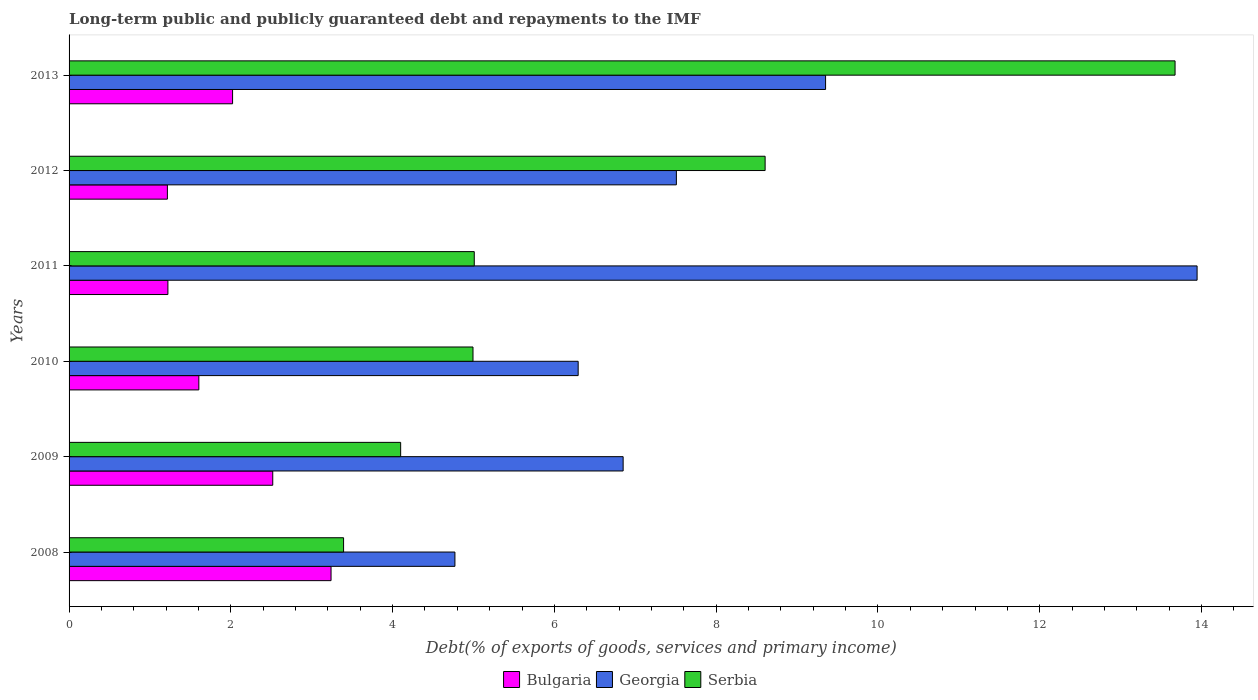How many different coloured bars are there?
Offer a terse response. 3. How many groups of bars are there?
Ensure brevity in your answer.  6. Are the number of bars per tick equal to the number of legend labels?
Make the answer very short. Yes. How many bars are there on the 3rd tick from the top?
Offer a very short reply. 3. What is the debt and repayments in Bulgaria in 2009?
Offer a terse response. 2.52. Across all years, what is the maximum debt and repayments in Bulgaria?
Ensure brevity in your answer.  3.24. Across all years, what is the minimum debt and repayments in Serbia?
Your answer should be very brief. 3.39. In which year was the debt and repayments in Serbia maximum?
Offer a very short reply. 2013. What is the total debt and repayments in Georgia in the graph?
Give a very brief answer. 48.72. What is the difference between the debt and repayments in Serbia in 2012 and that in 2013?
Give a very brief answer. -5.07. What is the difference between the debt and repayments in Georgia in 2011 and the debt and repayments in Serbia in 2008?
Your answer should be compact. 10.55. What is the average debt and repayments in Bulgaria per year?
Give a very brief answer. 1.97. In the year 2011, what is the difference between the debt and repayments in Serbia and debt and repayments in Bulgaria?
Provide a short and direct response. 3.79. What is the ratio of the debt and repayments in Georgia in 2009 to that in 2010?
Keep it short and to the point. 1.09. Is the debt and repayments in Bulgaria in 2008 less than that in 2012?
Your answer should be very brief. No. Is the difference between the debt and repayments in Serbia in 2010 and 2012 greater than the difference between the debt and repayments in Bulgaria in 2010 and 2012?
Your answer should be very brief. No. What is the difference between the highest and the second highest debt and repayments in Serbia?
Keep it short and to the point. 5.07. What is the difference between the highest and the lowest debt and repayments in Georgia?
Offer a terse response. 9.18. In how many years, is the debt and repayments in Georgia greater than the average debt and repayments in Georgia taken over all years?
Give a very brief answer. 2. Is the sum of the debt and repayments in Georgia in 2008 and 2012 greater than the maximum debt and repayments in Serbia across all years?
Provide a short and direct response. No. What does the 2nd bar from the top in 2012 represents?
Your response must be concise. Georgia. What does the 1st bar from the bottom in 2009 represents?
Offer a terse response. Bulgaria. Is it the case that in every year, the sum of the debt and repayments in Serbia and debt and repayments in Bulgaria is greater than the debt and repayments in Georgia?
Offer a very short reply. No. What is the difference between two consecutive major ticks on the X-axis?
Provide a succinct answer. 2. Does the graph contain grids?
Provide a short and direct response. No. Where does the legend appear in the graph?
Your response must be concise. Bottom center. How many legend labels are there?
Provide a succinct answer. 3. How are the legend labels stacked?
Offer a terse response. Horizontal. What is the title of the graph?
Keep it short and to the point. Long-term public and publicly guaranteed debt and repayments to the IMF. Does "Tonga" appear as one of the legend labels in the graph?
Ensure brevity in your answer.  No. What is the label or title of the X-axis?
Give a very brief answer. Debt(% of exports of goods, services and primary income). What is the Debt(% of exports of goods, services and primary income) in Bulgaria in 2008?
Your response must be concise. 3.24. What is the Debt(% of exports of goods, services and primary income) of Georgia in 2008?
Make the answer very short. 4.77. What is the Debt(% of exports of goods, services and primary income) in Serbia in 2008?
Your answer should be compact. 3.39. What is the Debt(% of exports of goods, services and primary income) of Bulgaria in 2009?
Offer a terse response. 2.52. What is the Debt(% of exports of goods, services and primary income) of Georgia in 2009?
Make the answer very short. 6.85. What is the Debt(% of exports of goods, services and primary income) of Serbia in 2009?
Provide a succinct answer. 4.1. What is the Debt(% of exports of goods, services and primary income) in Bulgaria in 2010?
Provide a succinct answer. 1.6. What is the Debt(% of exports of goods, services and primary income) in Georgia in 2010?
Offer a terse response. 6.29. What is the Debt(% of exports of goods, services and primary income) in Serbia in 2010?
Your answer should be compact. 4.99. What is the Debt(% of exports of goods, services and primary income) in Bulgaria in 2011?
Offer a terse response. 1.22. What is the Debt(% of exports of goods, services and primary income) in Georgia in 2011?
Your answer should be very brief. 13.95. What is the Debt(% of exports of goods, services and primary income) in Serbia in 2011?
Offer a terse response. 5.01. What is the Debt(% of exports of goods, services and primary income) of Bulgaria in 2012?
Your answer should be compact. 1.22. What is the Debt(% of exports of goods, services and primary income) of Georgia in 2012?
Your answer should be compact. 7.51. What is the Debt(% of exports of goods, services and primary income) of Serbia in 2012?
Your answer should be compact. 8.6. What is the Debt(% of exports of goods, services and primary income) of Bulgaria in 2013?
Provide a succinct answer. 2.02. What is the Debt(% of exports of goods, services and primary income) in Georgia in 2013?
Offer a terse response. 9.35. What is the Debt(% of exports of goods, services and primary income) of Serbia in 2013?
Your answer should be very brief. 13.67. Across all years, what is the maximum Debt(% of exports of goods, services and primary income) in Bulgaria?
Your answer should be compact. 3.24. Across all years, what is the maximum Debt(% of exports of goods, services and primary income) in Georgia?
Make the answer very short. 13.95. Across all years, what is the maximum Debt(% of exports of goods, services and primary income) in Serbia?
Provide a succinct answer. 13.67. Across all years, what is the minimum Debt(% of exports of goods, services and primary income) of Bulgaria?
Give a very brief answer. 1.22. Across all years, what is the minimum Debt(% of exports of goods, services and primary income) of Georgia?
Offer a very short reply. 4.77. Across all years, what is the minimum Debt(% of exports of goods, services and primary income) of Serbia?
Provide a short and direct response. 3.39. What is the total Debt(% of exports of goods, services and primary income) of Bulgaria in the graph?
Provide a succinct answer. 11.82. What is the total Debt(% of exports of goods, services and primary income) in Georgia in the graph?
Keep it short and to the point. 48.72. What is the total Debt(% of exports of goods, services and primary income) in Serbia in the graph?
Keep it short and to the point. 39.77. What is the difference between the Debt(% of exports of goods, services and primary income) of Bulgaria in 2008 and that in 2009?
Your response must be concise. 0.72. What is the difference between the Debt(% of exports of goods, services and primary income) of Georgia in 2008 and that in 2009?
Give a very brief answer. -2.08. What is the difference between the Debt(% of exports of goods, services and primary income) of Serbia in 2008 and that in 2009?
Offer a terse response. -0.71. What is the difference between the Debt(% of exports of goods, services and primary income) of Bulgaria in 2008 and that in 2010?
Your response must be concise. 1.63. What is the difference between the Debt(% of exports of goods, services and primary income) in Georgia in 2008 and that in 2010?
Keep it short and to the point. -1.52. What is the difference between the Debt(% of exports of goods, services and primary income) of Bulgaria in 2008 and that in 2011?
Offer a terse response. 2.02. What is the difference between the Debt(% of exports of goods, services and primary income) of Georgia in 2008 and that in 2011?
Keep it short and to the point. -9.18. What is the difference between the Debt(% of exports of goods, services and primary income) in Serbia in 2008 and that in 2011?
Make the answer very short. -1.62. What is the difference between the Debt(% of exports of goods, services and primary income) of Bulgaria in 2008 and that in 2012?
Keep it short and to the point. 2.02. What is the difference between the Debt(% of exports of goods, services and primary income) of Georgia in 2008 and that in 2012?
Provide a succinct answer. -2.74. What is the difference between the Debt(% of exports of goods, services and primary income) in Serbia in 2008 and that in 2012?
Ensure brevity in your answer.  -5.21. What is the difference between the Debt(% of exports of goods, services and primary income) in Bulgaria in 2008 and that in 2013?
Your answer should be compact. 1.22. What is the difference between the Debt(% of exports of goods, services and primary income) of Georgia in 2008 and that in 2013?
Provide a succinct answer. -4.58. What is the difference between the Debt(% of exports of goods, services and primary income) of Serbia in 2008 and that in 2013?
Keep it short and to the point. -10.28. What is the difference between the Debt(% of exports of goods, services and primary income) in Bulgaria in 2009 and that in 2010?
Your response must be concise. 0.91. What is the difference between the Debt(% of exports of goods, services and primary income) in Georgia in 2009 and that in 2010?
Keep it short and to the point. 0.56. What is the difference between the Debt(% of exports of goods, services and primary income) of Serbia in 2009 and that in 2010?
Give a very brief answer. -0.89. What is the difference between the Debt(% of exports of goods, services and primary income) in Bulgaria in 2009 and that in 2011?
Provide a succinct answer. 1.3. What is the difference between the Debt(% of exports of goods, services and primary income) of Georgia in 2009 and that in 2011?
Your answer should be very brief. -7.1. What is the difference between the Debt(% of exports of goods, services and primary income) of Serbia in 2009 and that in 2011?
Offer a terse response. -0.91. What is the difference between the Debt(% of exports of goods, services and primary income) in Bulgaria in 2009 and that in 2012?
Your response must be concise. 1.3. What is the difference between the Debt(% of exports of goods, services and primary income) of Georgia in 2009 and that in 2012?
Provide a succinct answer. -0.66. What is the difference between the Debt(% of exports of goods, services and primary income) in Serbia in 2009 and that in 2012?
Keep it short and to the point. -4.51. What is the difference between the Debt(% of exports of goods, services and primary income) in Bulgaria in 2009 and that in 2013?
Your answer should be very brief. 0.5. What is the difference between the Debt(% of exports of goods, services and primary income) in Georgia in 2009 and that in 2013?
Make the answer very short. -2.5. What is the difference between the Debt(% of exports of goods, services and primary income) of Serbia in 2009 and that in 2013?
Give a very brief answer. -9.57. What is the difference between the Debt(% of exports of goods, services and primary income) of Bulgaria in 2010 and that in 2011?
Provide a short and direct response. 0.38. What is the difference between the Debt(% of exports of goods, services and primary income) of Georgia in 2010 and that in 2011?
Your answer should be very brief. -7.65. What is the difference between the Debt(% of exports of goods, services and primary income) of Serbia in 2010 and that in 2011?
Your answer should be very brief. -0.02. What is the difference between the Debt(% of exports of goods, services and primary income) in Bulgaria in 2010 and that in 2012?
Offer a terse response. 0.39. What is the difference between the Debt(% of exports of goods, services and primary income) in Georgia in 2010 and that in 2012?
Your answer should be compact. -1.21. What is the difference between the Debt(% of exports of goods, services and primary income) in Serbia in 2010 and that in 2012?
Your answer should be compact. -3.61. What is the difference between the Debt(% of exports of goods, services and primary income) in Bulgaria in 2010 and that in 2013?
Your answer should be compact. -0.42. What is the difference between the Debt(% of exports of goods, services and primary income) of Georgia in 2010 and that in 2013?
Offer a terse response. -3.06. What is the difference between the Debt(% of exports of goods, services and primary income) in Serbia in 2010 and that in 2013?
Provide a short and direct response. -8.68. What is the difference between the Debt(% of exports of goods, services and primary income) of Bulgaria in 2011 and that in 2012?
Provide a succinct answer. 0.01. What is the difference between the Debt(% of exports of goods, services and primary income) in Georgia in 2011 and that in 2012?
Provide a succinct answer. 6.44. What is the difference between the Debt(% of exports of goods, services and primary income) in Serbia in 2011 and that in 2012?
Keep it short and to the point. -3.6. What is the difference between the Debt(% of exports of goods, services and primary income) in Bulgaria in 2011 and that in 2013?
Offer a very short reply. -0.8. What is the difference between the Debt(% of exports of goods, services and primary income) of Georgia in 2011 and that in 2013?
Keep it short and to the point. 4.59. What is the difference between the Debt(% of exports of goods, services and primary income) in Serbia in 2011 and that in 2013?
Provide a succinct answer. -8.66. What is the difference between the Debt(% of exports of goods, services and primary income) in Bulgaria in 2012 and that in 2013?
Your answer should be very brief. -0.81. What is the difference between the Debt(% of exports of goods, services and primary income) of Georgia in 2012 and that in 2013?
Your answer should be compact. -1.84. What is the difference between the Debt(% of exports of goods, services and primary income) of Serbia in 2012 and that in 2013?
Your answer should be compact. -5.07. What is the difference between the Debt(% of exports of goods, services and primary income) of Bulgaria in 2008 and the Debt(% of exports of goods, services and primary income) of Georgia in 2009?
Provide a short and direct response. -3.61. What is the difference between the Debt(% of exports of goods, services and primary income) in Bulgaria in 2008 and the Debt(% of exports of goods, services and primary income) in Serbia in 2009?
Your answer should be very brief. -0.86. What is the difference between the Debt(% of exports of goods, services and primary income) in Georgia in 2008 and the Debt(% of exports of goods, services and primary income) in Serbia in 2009?
Your answer should be very brief. 0.67. What is the difference between the Debt(% of exports of goods, services and primary income) of Bulgaria in 2008 and the Debt(% of exports of goods, services and primary income) of Georgia in 2010?
Offer a very short reply. -3.06. What is the difference between the Debt(% of exports of goods, services and primary income) of Bulgaria in 2008 and the Debt(% of exports of goods, services and primary income) of Serbia in 2010?
Offer a very short reply. -1.75. What is the difference between the Debt(% of exports of goods, services and primary income) in Georgia in 2008 and the Debt(% of exports of goods, services and primary income) in Serbia in 2010?
Offer a terse response. -0.22. What is the difference between the Debt(% of exports of goods, services and primary income) of Bulgaria in 2008 and the Debt(% of exports of goods, services and primary income) of Georgia in 2011?
Keep it short and to the point. -10.71. What is the difference between the Debt(% of exports of goods, services and primary income) of Bulgaria in 2008 and the Debt(% of exports of goods, services and primary income) of Serbia in 2011?
Your answer should be very brief. -1.77. What is the difference between the Debt(% of exports of goods, services and primary income) in Georgia in 2008 and the Debt(% of exports of goods, services and primary income) in Serbia in 2011?
Provide a succinct answer. -0.24. What is the difference between the Debt(% of exports of goods, services and primary income) of Bulgaria in 2008 and the Debt(% of exports of goods, services and primary income) of Georgia in 2012?
Provide a succinct answer. -4.27. What is the difference between the Debt(% of exports of goods, services and primary income) in Bulgaria in 2008 and the Debt(% of exports of goods, services and primary income) in Serbia in 2012?
Make the answer very short. -5.37. What is the difference between the Debt(% of exports of goods, services and primary income) in Georgia in 2008 and the Debt(% of exports of goods, services and primary income) in Serbia in 2012?
Make the answer very short. -3.83. What is the difference between the Debt(% of exports of goods, services and primary income) of Bulgaria in 2008 and the Debt(% of exports of goods, services and primary income) of Georgia in 2013?
Your answer should be very brief. -6.11. What is the difference between the Debt(% of exports of goods, services and primary income) in Bulgaria in 2008 and the Debt(% of exports of goods, services and primary income) in Serbia in 2013?
Your answer should be very brief. -10.43. What is the difference between the Debt(% of exports of goods, services and primary income) in Georgia in 2008 and the Debt(% of exports of goods, services and primary income) in Serbia in 2013?
Give a very brief answer. -8.9. What is the difference between the Debt(% of exports of goods, services and primary income) in Bulgaria in 2009 and the Debt(% of exports of goods, services and primary income) in Georgia in 2010?
Provide a short and direct response. -3.78. What is the difference between the Debt(% of exports of goods, services and primary income) of Bulgaria in 2009 and the Debt(% of exports of goods, services and primary income) of Serbia in 2010?
Offer a very short reply. -2.48. What is the difference between the Debt(% of exports of goods, services and primary income) of Georgia in 2009 and the Debt(% of exports of goods, services and primary income) of Serbia in 2010?
Your answer should be compact. 1.86. What is the difference between the Debt(% of exports of goods, services and primary income) of Bulgaria in 2009 and the Debt(% of exports of goods, services and primary income) of Georgia in 2011?
Offer a very short reply. -11.43. What is the difference between the Debt(% of exports of goods, services and primary income) of Bulgaria in 2009 and the Debt(% of exports of goods, services and primary income) of Serbia in 2011?
Ensure brevity in your answer.  -2.49. What is the difference between the Debt(% of exports of goods, services and primary income) in Georgia in 2009 and the Debt(% of exports of goods, services and primary income) in Serbia in 2011?
Keep it short and to the point. 1.84. What is the difference between the Debt(% of exports of goods, services and primary income) in Bulgaria in 2009 and the Debt(% of exports of goods, services and primary income) in Georgia in 2012?
Provide a succinct answer. -4.99. What is the difference between the Debt(% of exports of goods, services and primary income) of Bulgaria in 2009 and the Debt(% of exports of goods, services and primary income) of Serbia in 2012?
Your answer should be very brief. -6.09. What is the difference between the Debt(% of exports of goods, services and primary income) of Georgia in 2009 and the Debt(% of exports of goods, services and primary income) of Serbia in 2012?
Ensure brevity in your answer.  -1.76. What is the difference between the Debt(% of exports of goods, services and primary income) in Bulgaria in 2009 and the Debt(% of exports of goods, services and primary income) in Georgia in 2013?
Provide a short and direct response. -6.83. What is the difference between the Debt(% of exports of goods, services and primary income) of Bulgaria in 2009 and the Debt(% of exports of goods, services and primary income) of Serbia in 2013?
Give a very brief answer. -11.15. What is the difference between the Debt(% of exports of goods, services and primary income) in Georgia in 2009 and the Debt(% of exports of goods, services and primary income) in Serbia in 2013?
Make the answer very short. -6.82. What is the difference between the Debt(% of exports of goods, services and primary income) of Bulgaria in 2010 and the Debt(% of exports of goods, services and primary income) of Georgia in 2011?
Your answer should be very brief. -12.34. What is the difference between the Debt(% of exports of goods, services and primary income) in Bulgaria in 2010 and the Debt(% of exports of goods, services and primary income) in Serbia in 2011?
Provide a short and direct response. -3.41. What is the difference between the Debt(% of exports of goods, services and primary income) in Georgia in 2010 and the Debt(% of exports of goods, services and primary income) in Serbia in 2011?
Your answer should be compact. 1.28. What is the difference between the Debt(% of exports of goods, services and primary income) of Bulgaria in 2010 and the Debt(% of exports of goods, services and primary income) of Georgia in 2012?
Your answer should be compact. -5.9. What is the difference between the Debt(% of exports of goods, services and primary income) in Bulgaria in 2010 and the Debt(% of exports of goods, services and primary income) in Serbia in 2012?
Ensure brevity in your answer.  -7. What is the difference between the Debt(% of exports of goods, services and primary income) of Georgia in 2010 and the Debt(% of exports of goods, services and primary income) of Serbia in 2012?
Give a very brief answer. -2.31. What is the difference between the Debt(% of exports of goods, services and primary income) of Bulgaria in 2010 and the Debt(% of exports of goods, services and primary income) of Georgia in 2013?
Give a very brief answer. -7.75. What is the difference between the Debt(% of exports of goods, services and primary income) in Bulgaria in 2010 and the Debt(% of exports of goods, services and primary income) in Serbia in 2013?
Ensure brevity in your answer.  -12.07. What is the difference between the Debt(% of exports of goods, services and primary income) of Georgia in 2010 and the Debt(% of exports of goods, services and primary income) of Serbia in 2013?
Make the answer very short. -7.38. What is the difference between the Debt(% of exports of goods, services and primary income) in Bulgaria in 2011 and the Debt(% of exports of goods, services and primary income) in Georgia in 2012?
Provide a short and direct response. -6.29. What is the difference between the Debt(% of exports of goods, services and primary income) of Bulgaria in 2011 and the Debt(% of exports of goods, services and primary income) of Serbia in 2012?
Your answer should be compact. -7.38. What is the difference between the Debt(% of exports of goods, services and primary income) of Georgia in 2011 and the Debt(% of exports of goods, services and primary income) of Serbia in 2012?
Keep it short and to the point. 5.34. What is the difference between the Debt(% of exports of goods, services and primary income) of Bulgaria in 2011 and the Debt(% of exports of goods, services and primary income) of Georgia in 2013?
Your answer should be compact. -8.13. What is the difference between the Debt(% of exports of goods, services and primary income) in Bulgaria in 2011 and the Debt(% of exports of goods, services and primary income) in Serbia in 2013?
Offer a terse response. -12.45. What is the difference between the Debt(% of exports of goods, services and primary income) of Georgia in 2011 and the Debt(% of exports of goods, services and primary income) of Serbia in 2013?
Keep it short and to the point. 0.27. What is the difference between the Debt(% of exports of goods, services and primary income) in Bulgaria in 2012 and the Debt(% of exports of goods, services and primary income) in Georgia in 2013?
Ensure brevity in your answer.  -8.14. What is the difference between the Debt(% of exports of goods, services and primary income) in Bulgaria in 2012 and the Debt(% of exports of goods, services and primary income) in Serbia in 2013?
Your answer should be very brief. -12.46. What is the difference between the Debt(% of exports of goods, services and primary income) of Georgia in 2012 and the Debt(% of exports of goods, services and primary income) of Serbia in 2013?
Your answer should be very brief. -6.17. What is the average Debt(% of exports of goods, services and primary income) in Bulgaria per year?
Provide a short and direct response. 1.97. What is the average Debt(% of exports of goods, services and primary income) of Georgia per year?
Your response must be concise. 8.12. What is the average Debt(% of exports of goods, services and primary income) in Serbia per year?
Your response must be concise. 6.63. In the year 2008, what is the difference between the Debt(% of exports of goods, services and primary income) of Bulgaria and Debt(% of exports of goods, services and primary income) of Georgia?
Provide a succinct answer. -1.53. In the year 2008, what is the difference between the Debt(% of exports of goods, services and primary income) of Bulgaria and Debt(% of exports of goods, services and primary income) of Serbia?
Your answer should be compact. -0.15. In the year 2008, what is the difference between the Debt(% of exports of goods, services and primary income) in Georgia and Debt(% of exports of goods, services and primary income) in Serbia?
Give a very brief answer. 1.38. In the year 2009, what is the difference between the Debt(% of exports of goods, services and primary income) in Bulgaria and Debt(% of exports of goods, services and primary income) in Georgia?
Keep it short and to the point. -4.33. In the year 2009, what is the difference between the Debt(% of exports of goods, services and primary income) of Bulgaria and Debt(% of exports of goods, services and primary income) of Serbia?
Keep it short and to the point. -1.58. In the year 2009, what is the difference between the Debt(% of exports of goods, services and primary income) in Georgia and Debt(% of exports of goods, services and primary income) in Serbia?
Your response must be concise. 2.75. In the year 2010, what is the difference between the Debt(% of exports of goods, services and primary income) in Bulgaria and Debt(% of exports of goods, services and primary income) in Georgia?
Your response must be concise. -4.69. In the year 2010, what is the difference between the Debt(% of exports of goods, services and primary income) of Bulgaria and Debt(% of exports of goods, services and primary income) of Serbia?
Your answer should be very brief. -3.39. In the year 2010, what is the difference between the Debt(% of exports of goods, services and primary income) in Georgia and Debt(% of exports of goods, services and primary income) in Serbia?
Offer a very short reply. 1.3. In the year 2011, what is the difference between the Debt(% of exports of goods, services and primary income) in Bulgaria and Debt(% of exports of goods, services and primary income) in Georgia?
Your answer should be compact. -12.72. In the year 2011, what is the difference between the Debt(% of exports of goods, services and primary income) of Bulgaria and Debt(% of exports of goods, services and primary income) of Serbia?
Offer a very short reply. -3.79. In the year 2011, what is the difference between the Debt(% of exports of goods, services and primary income) of Georgia and Debt(% of exports of goods, services and primary income) of Serbia?
Provide a short and direct response. 8.94. In the year 2012, what is the difference between the Debt(% of exports of goods, services and primary income) in Bulgaria and Debt(% of exports of goods, services and primary income) in Georgia?
Ensure brevity in your answer.  -6.29. In the year 2012, what is the difference between the Debt(% of exports of goods, services and primary income) of Bulgaria and Debt(% of exports of goods, services and primary income) of Serbia?
Your answer should be compact. -7.39. In the year 2012, what is the difference between the Debt(% of exports of goods, services and primary income) in Georgia and Debt(% of exports of goods, services and primary income) in Serbia?
Make the answer very short. -1.1. In the year 2013, what is the difference between the Debt(% of exports of goods, services and primary income) of Bulgaria and Debt(% of exports of goods, services and primary income) of Georgia?
Your answer should be very brief. -7.33. In the year 2013, what is the difference between the Debt(% of exports of goods, services and primary income) in Bulgaria and Debt(% of exports of goods, services and primary income) in Serbia?
Your response must be concise. -11.65. In the year 2013, what is the difference between the Debt(% of exports of goods, services and primary income) in Georgia and Debt(% of exports of goods, services and primary income) in Serbia?
Offer a terse response. -4.32. What is the ratio of the Debt(% of exports of goods, services and primary income) in Bulgaria in 2008 to that in 2009?
Provide a short and direct response. 1.29. What is the ratio of the Debt(% of exports of goods, services and primary income) of Georgia in 2008 to that in 2009?
Provide a short and direct response. 0.7. What is the ratio of the Debt(% of exports of goods, services and primary income) of Serbia in 2008 to that in 2009?
Offer a terse response. 0.83. What is the ratio of the Debt(% of exports of goods, services and primary income) of Bulgaria in 2008 to that in 2010?
Offer a terse response. 2.02. What is the ratio of the Debt(% of exports of goods, services and primary income) in Georgia in 2008 to that in 2010?
Provide a succinct answer. 0.76. What is the ratio of the Debt(% of exports of goods, services and primary income) in Serbia in 2008 to that in 2010?
Provide a succinct answer. 0.68. What is the ratio of the Debt(% of exports of goods, services and primary income) in Bulgaria in 2008 to that in 2011?
Provide a short and direct response. 2.65. What is the ratio of the Debt(% of exports of goods, services and primary income) of Georgia in 2008 to that in 2011?
Offer a very short reply. 0.34. What is the ratio of the Debt(% of exports of goods, services and primary income) of Serbia in 2008 to that in 2011?
Offer a very short reply. 0.68. What is the ratio of the Debt(% of exports of goods, services and primary income) in Bulgaria in 2008 to that in 2012?
Offer a very short reply. 2.66. What is the ratio of the Debt(% of exports of goods, services and primary income) of Georgia in 2008 to that in 2012?
Your answer should be very brief. 0.64. What is the ratio of the Debt(% of exports of goods, services and primary income) of Serbia in 2008 to that in 2012?
Offer a terse response. 0.39. What is the ratio of the Debt(% of exports of goods, services and primary income) of Bulgaria in 2008 to that in 2013?
Make the answer very short. 1.6. What is the ratio of the Debt(% of exports of goods, services and primary income) in Georgia in 2008 to that in 2013?
Your answer should be very brief. 0.51. What is the ratio of the Debt(% of exports of goods, services and primary income) of Serbia in 2008 to that in 2013?
Provide a succinct answer. 0.25. What is the ratio of the Debt(% of exports of goods, services and primary income) of Bulgaria in 2009 to that in 2010?
Ensure brevity in your answer.  1.57. What is the ratio of the Debt(% of exports of goods, services and primary income) in Georgia in 2009 to that in 2010?
Provide a short and direct response. 1.09. What is the ratio of the Debt(% of exports of goods, services and primary income) of Serbia in 2009 to that in 2010?
Give a very brief answer. 0.82. What is the ratio of the Debt(% of exports of goods, services and primary income) in Bulgaria in 2009 to that in 2011?
Your answer should be compact. 2.06. What is the ratio of the Debt(% of exports of goods, services and primary income) in Georgia in 2009 to that in 2011?
Offer a terse response. 0.49. What is the ratio of the Debt(% of exports of goods, services and primary income) in Serbia in 2009 to that in 2011?
Make the answer very short. 0.82. What is the ratio of the Debt(% of exports of goods, services and primary income) of Bulgaria in 2009 to that in 2012?
Ensure brevity in your answer.  2.07. What is the ratio of the Debt(% of exports of goods, services and primary income) of Georgia in 2009 to that in 2012?
Your response must be concise. 0.91. What is the ratio of the Debt(% of exports of goods, services and primary income) of Serbia in 2009 to that in 2012?
Your response must be concise. 0.48. What is the ratio of the Debt(% of exports of goods, services and primary income) in Bulgaria in 2009 to that in 2013?
Offer a terse response. 1.25. What is the ratio of the Debt(% of exports of goods, services and primary income) of Georgia in 2009 to that in 2013?
Provide a succinct answer. 0.73. What is the ratio of the Debt(% of exports of goods, services and primary income) of Serbia in 2009 to that in 2013?
Offer a very short reply. 0.3. What is the ratio of the Debt(% of exports of goods, services and primary income) in Bulgaria in 2010 to that in 2011?
Offer a terse response. 1.31. What is the ratio of the Debt(% of exports of goods, services and primary income) of Georgia in 2010 to that in 2011?
Your answer should be compact. 0.45. What is the ratio of the Debt(% of exports of goods, services and primary income) in Serbia in 2010 to that in 2011?
Provide a short and direct response. 1. What is the ratio of the Debt(% of exports of goods, services and primary income) of Bulgaria in 2010 to that in 2012?
Offer a terse response. 1.32. What is the ratio of the Debt(% of exports of goods, services and primary income) in Georgia in 2010 to that in 2012?
Your response must be concise. 0.84. What is the ratio of the Debt(% of exports of goods, services and primary income) in Serbia in 2010 to that in 2012?
Provide a succinct answer. 0.58. What is the ratio of the Debt(% of exports of goods, services and primary income) of Bulgaria in 2010 to that in 2013?
Ensure brevity in your answer.  0.79. What is the ratio of the Debt(% of exports of goods, services and primary income) of Georgia in 2010 to that in 2013?
Give a very brief answer. 0.67. What is the ratio of the Debt(% of exports of goods, services and primary income) of Serbia in 2010 to that in 2013?
Make the answer very short. 0.37. What is the ratio of the Debt(% of exports of goods, services and primary income) in Georgia in 2011 to that in 2012?
Make the answer very short. 1.86. What is the ratio of the Debt(% of exports of goods, services and primary income) of Serbia in 2011 to that in 2012?
Offer a terse response. 0.58. What is the ratio of the Debt(% of exports of goods, services and primary income) of Bulgaria in 2011 to that in 2013?
Provide a succinct answer. 0.6. What is the ratio of the Debt(% of exports of goods, services and primary income) in Georgia in 2011 to that in 2013?
Provide a short and direct response. 1.49. What is the ratio of the Debt(% of exports of goods, services and primary income) in Serbia in 2011 to that in 2013?
Offer a terse response. 0.37. What is the ratio of the Debt(% of exports of goods, services and primary income) of Bulgaria in 2012 to that in 2013?
Your response must be concise. 0.6. What is the ratio of the Debt(% of exports of goods, services and primary income) of Georgia in 2012 to that in 2013?
Offer a terse response. 0.8. What is the ratio of the Debt(% of exports of goods, services and primary income) of Serbia in 2012 to that in 2013?
Your response must be concise. 0.63. What is the difference between the highest and the second highest Debt(% of exports of goods, services and primary income) of Bulgaria?
Offer a terse response. 0.72. What is the difference between the highest and the second highest Debt(% of exports of goods, services and primary income) in Georgia?
Provide a succinct answer. 4.59. What is the difference between the highest and the second highest Debt(% of exports of goods, services and primary income) of Serbia?
Offer a terse response. 5.07. What is the difference between the highest and the lowest Debt(% of exports of goods, services and primary income) in Bulgaria?
Give a very brief answer. 2.02. What is the difference between the highest and the lowest Debt(% of exports of goods, services and primary income) in Georgia?
Keep it short and to the point. 9.18. What is the difference between the highest and the lowest Debt(% of exports of goods, services and primary income) of Serbia?
Ensure brevity in your answer.  10.28. 